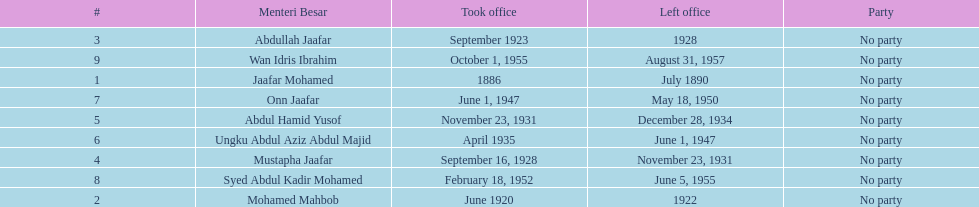Who was the first to take office? Jaafar Mohamed. 